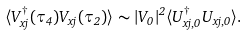<formula> <loc_0><loc_0><loc_500><loc_500>\langle V ^ { \dagger } _ { x j } ( \tau _ { 4 } ) V _ { x j } ( \tau _ { 2 } ) \rangle \sim | V _ { 0 } | ^ { 2 } \langle U ^ { \dagger } _ { x j , 0 } U _ { x j , 0 } \rangle .</formula> 